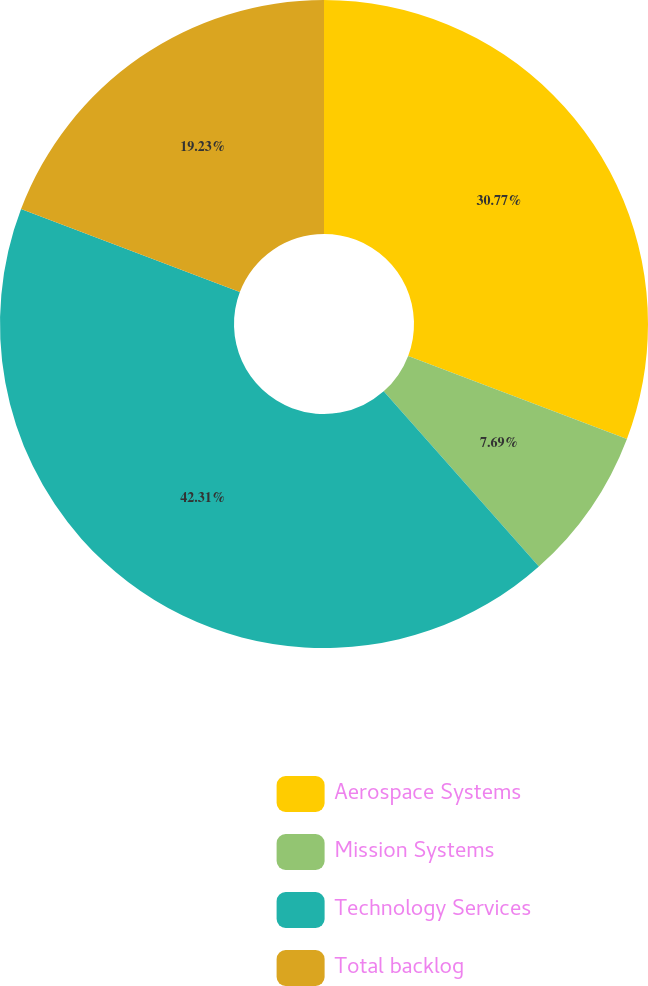Convert chart to OTSL. <chart><loc_0><loc_0><loc_500><loc_500><pie_chart><fcel>Aerospace Systems<fcel>Mission Systems<fcel>Technology Services<fcel>Total backlog<nl><fcel>30.77%<fcel>7.69%<fcel>42.31%<fcel>19.23%<nl></chart> 